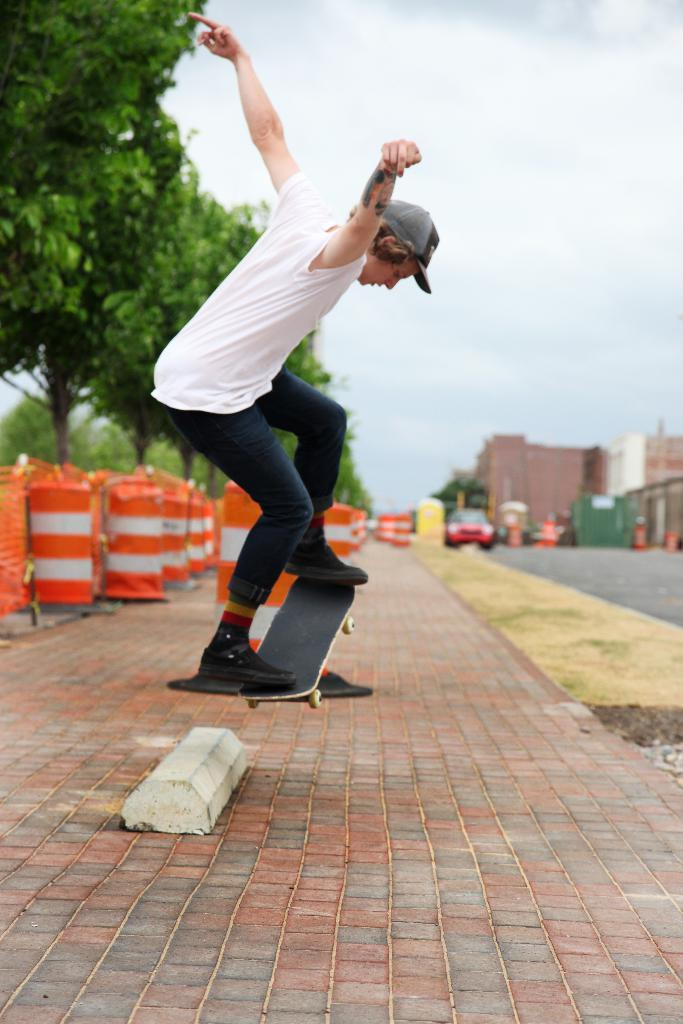What is the main subject of the image? There is a person in the image. Can you describe the person's attire? The person is wearing a cap. What activity is the person engaged in? The person is skating with a skateboard. What safety features are present in the image? There are safety pillars in the image. What type of surface can be seen in the image? There is a path in the image. What else is present in the image besides the person and the path? Vehicles, trees, buildings, and a cloudy sky are present in the image. What type of cart can be seen carrying a vein in the image? There is no cart or vein present in the image. What type of land is visible in the image? The image does not show any specific type of land; it features a path, trees, and buildings. 